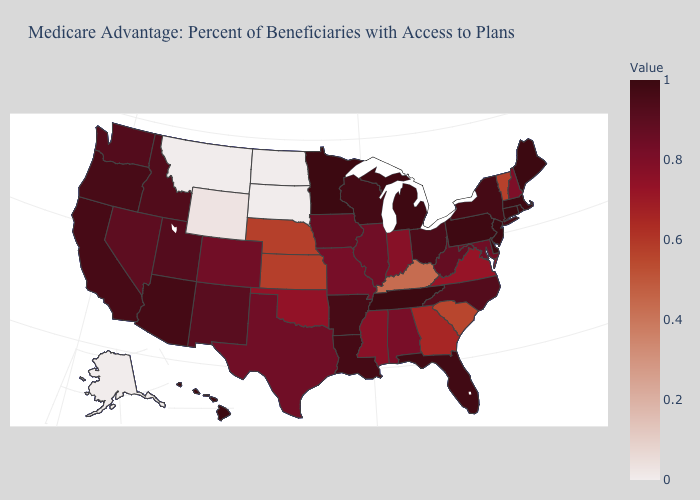Among the states that border South Dakota , does North Dakota have the lowest value?
Quick response, please. Yes. Does Missouri have a higher value than Wisconsin?
Quick response, please. No. Which states have the lowest value in the Northeast?
Short answer required. Vermont. Among the states that border Utah , which have the highest value?
Keep it brief. Arizona. Does New Hampshire have a lower value than Louisiana?
Give a very brief answer. Yes. Among the states that border South Carolina , does North Carolina have the lowest value?
Keep it brief. No. 